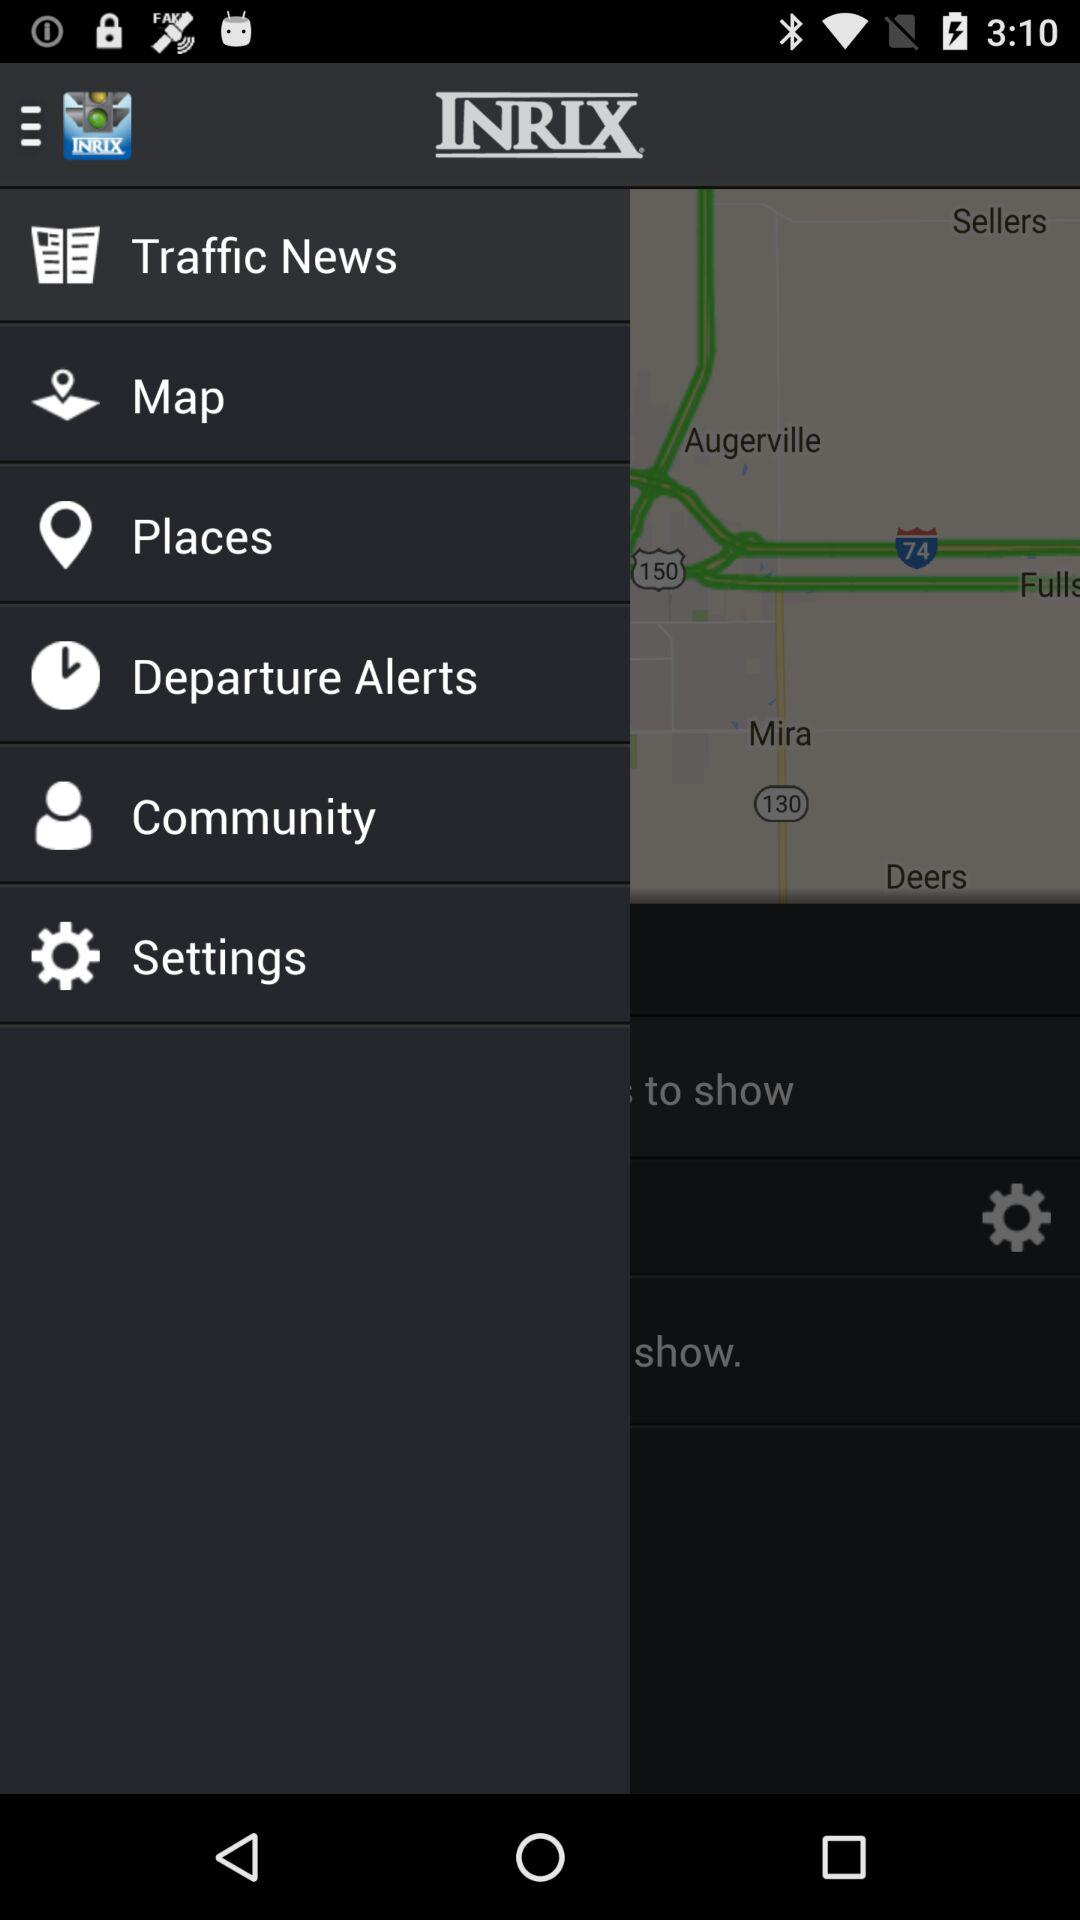What is the name of the application? The name of the application is "INRIX Traffic Maps & GPS". 